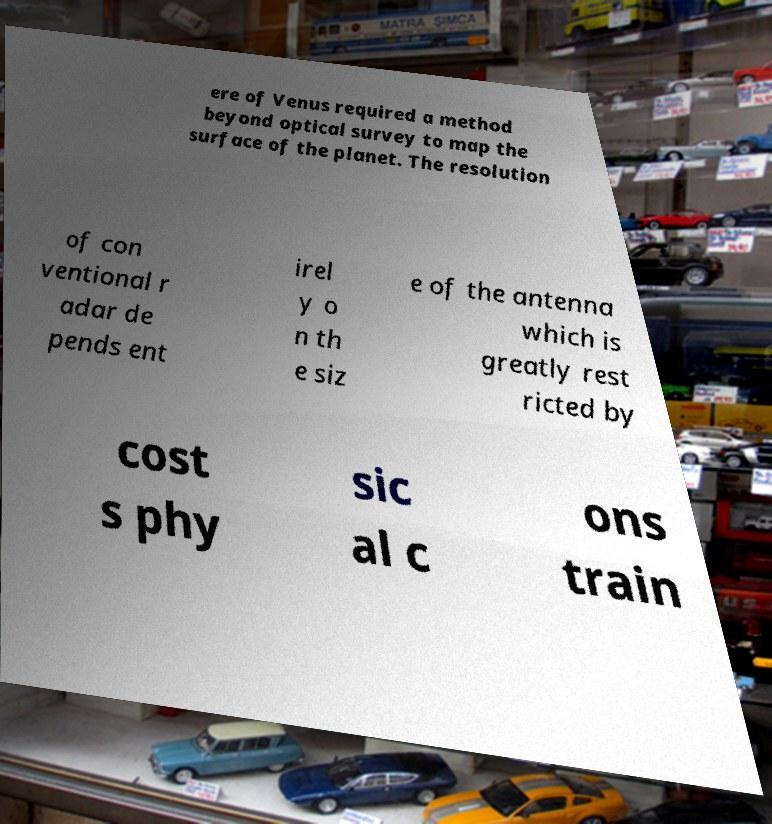Please identify and transcribe the text found in this image. ere of Venus required a method beyond optical survey to map the surface of the planet. The resolution of con ventional r adar de pends ent irel y o n th e siz e of the antenna which is greatly rest ricted by cost s phy sic al c ons train 